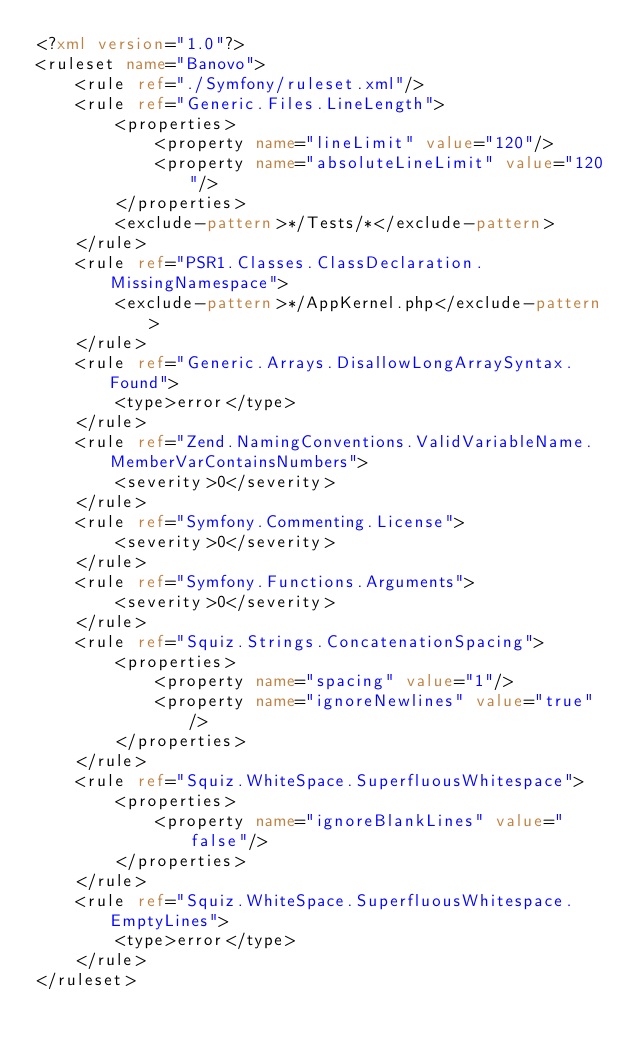Convert code to text. <code><loc_0><loc_0><loc_500><loc_500><_XML_><?xml version="1.0"?>
<ruleset name="Banovo">
    <rule ref="./Symfony/ruleset.xml"/>
    <rule ref="Generic.Files.LineLength">
        <properties>
            <property name="lineLimit" value="120"/>
            <property name="absoluteLineLimit" value="120"/>
        </properties>
        <exclude-pattern>*/Tests/*</exclude-pattern>
    </rule>
    <rule ref="PSR1.Classes.ClassDeclaration.MissingNamespace">
        <exclude-pattern>*/AppKernel.php</exclude-pattern>
    </rule>
    <rule ref="Generic.Arrays.DisallowLongArraySyntax.Found">
        <type>error</type>
    </rule>
    <rule ref="Zend.NamingConventions.ValidVariableName.MemberVarContainsNumbers">
        <severity>0</severity>
    </rule>
    <rule ref="Symfony.Commenting.License">
        <severity>0</severity>
    </rule>
    <rule ref="Symfony.Functions.Arguments">
        <severity>0</severity>
    </rule>
    <rule ref="Squiz.Strings.ConcatenationSpacing">
        <properties>
            <property name="spacing" value="1"/>
            <property name="ignoreNewlines" value="true" />
        </properties>
    </rule>
    <rule ref="Squiz.WhiteSpace.SuperfluousWhitespace">
        <properties>
            <property name="ignoreBlankLines" value="false"/>
        </properties>
    </rule>
    <rule ref="Squiz.WhiteSpace.SuperfluousWhitespace.EmptyLines">
        <type>error</type>
    </rule>
</ruleset>
</code> 